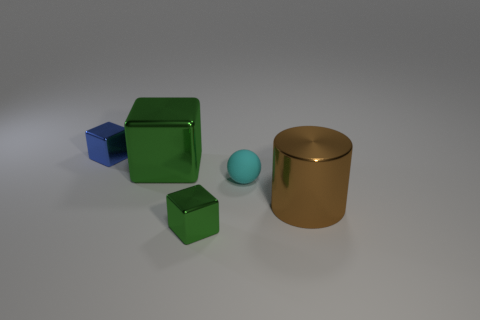Subtract all green metal cubes. How many cubes are left? 1 Subtract all green blocks. How many blocks are left? 1 Add 2 metallic cylinders. How many objects exist? 7 Subtract all cylinders. How many objects are left? 4 Subtract all small gray metallic spheres. Subtract all small spheres. How many objects are left? 4 Add 2 green metal blocks. How many green metal blocks are left? 4 Add 3 green shiny cubes. How many green shiny cubes exist? 5 Subtract 1 cyan balls. How many objects are left? 4 Subtract all blue cubes. Subtract all brown cylinders. How many cubes are left? 2 Subtract all cyan spheres. How many green cubes are left? 2 